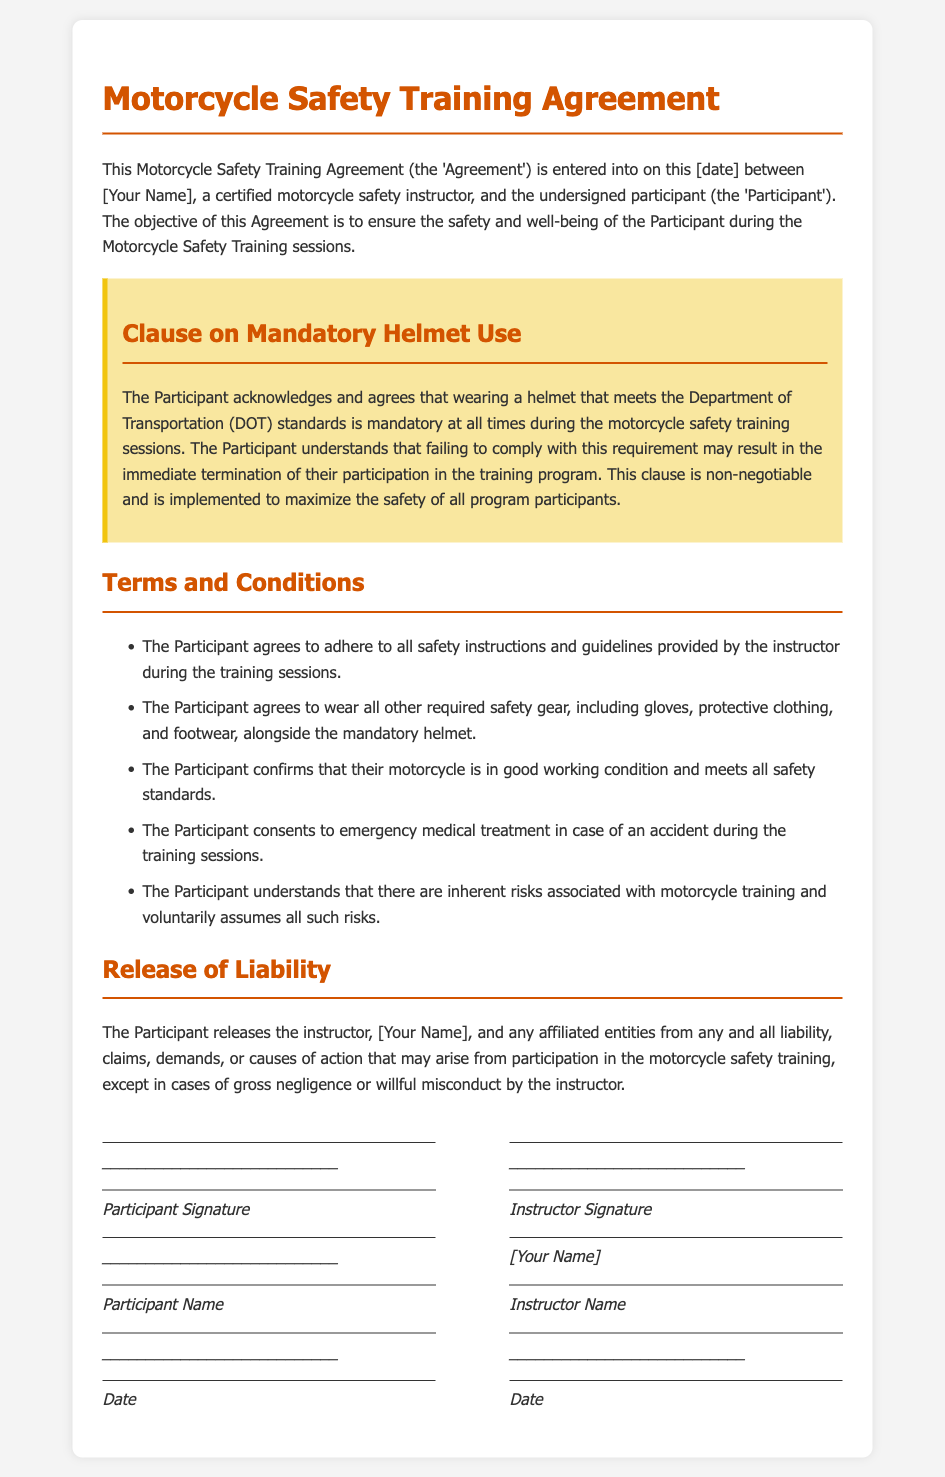What is the title of the document? The title is specified at the top of the document before the introductory paragraph.
Answer: Motorcycle Safety Training Agreement What is mandatory for the Participant during training sessions? The Clause on Mandatory Helmet Use clearly states what the Participant must wear during the sessions.
Answer: Helmet Who is the certified motorcycle safety instructor? The instructor's name appears in the introductory paragraph and at the end of the document.
Answer: [Your Name] What may happen if the Participant fails to wear a helmet? The consequences of not complying with helmet requirements are detailed in the Clause on Mandatory Helmet Use.
Answer: Termination What does the Participant agree to wear alongside the mandatory helmet? The Terms and Conditions include additional safety gear the Participant must wear.
Answer: Safety gear What must the Participant confirm about their motorcycle? The document specifies a requirement regarding the condition of the motorcycle in the Terms section.
Answer: Good working condition What type of treatment does the Participant consent to in case of an accident? Emergency medical treatment is mentioned in the Terms and Conditions section.
Answer: Emergency medical treatment What is released in the Release of Liability? The Release of Liability specifies who is exempt from liability claims resulting from participation in training.
Answer: Instructor What is the document's purpose? The purpose of the agreement is mentioned in the introductory paragraph.
Answer: Safety and well-being 